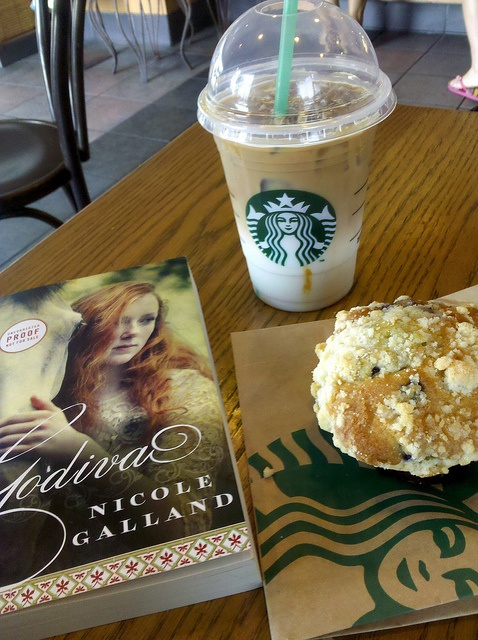Describe the objects in this image and their specific colors. I can see book in olive, black, gray, tan, and darkgray tones, cup in olive, darkgray, lightgray, and tan tones, dining table in olive, maroon, and gray tones, cake in olive, tan, khaki, and beige tones, and chair in olive, black, gray, and darkgray tones in this image. 